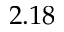Convert formula to latex. <formula><loc_0><loc_0><loc_500><loc_500>2 . 1 8</formula> 